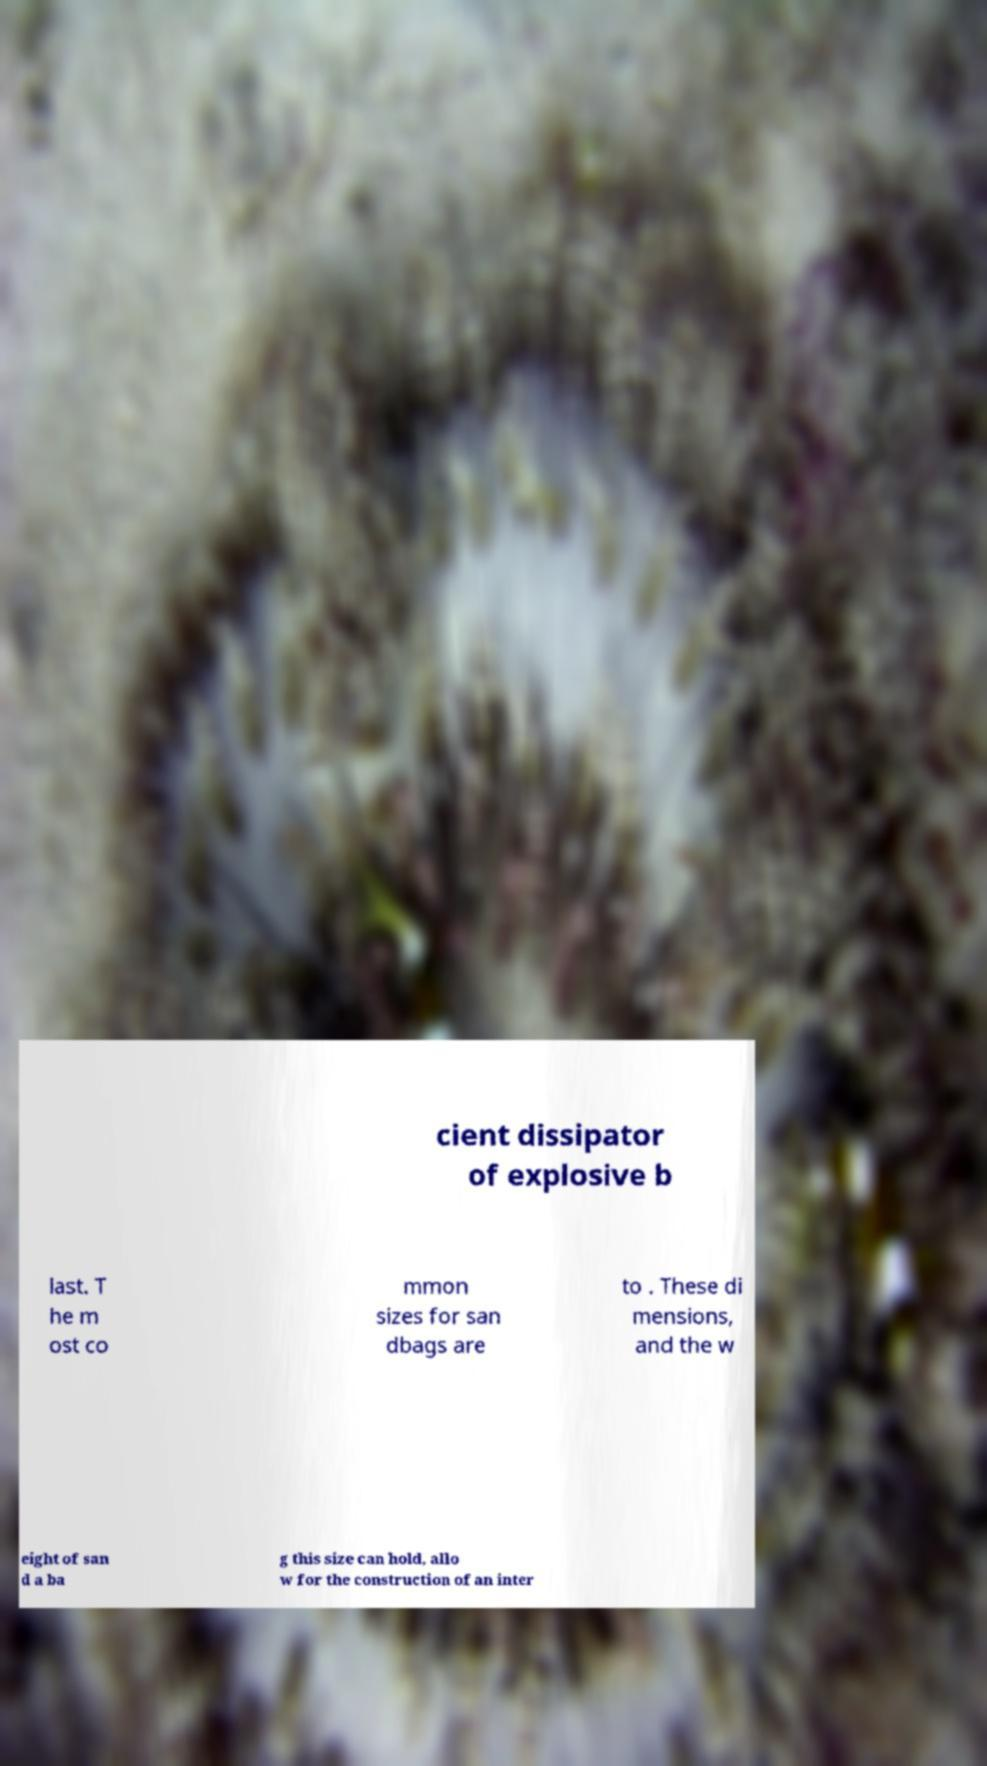Could you assist in decoding the text presented in this image and type it out clearly? cient dissipator of explosive b last. T he m ost co mmon sizes for san dbags are to . These di mensions, and the w eight of san d a ba g this size can hold, allo w for the construction of an inter 